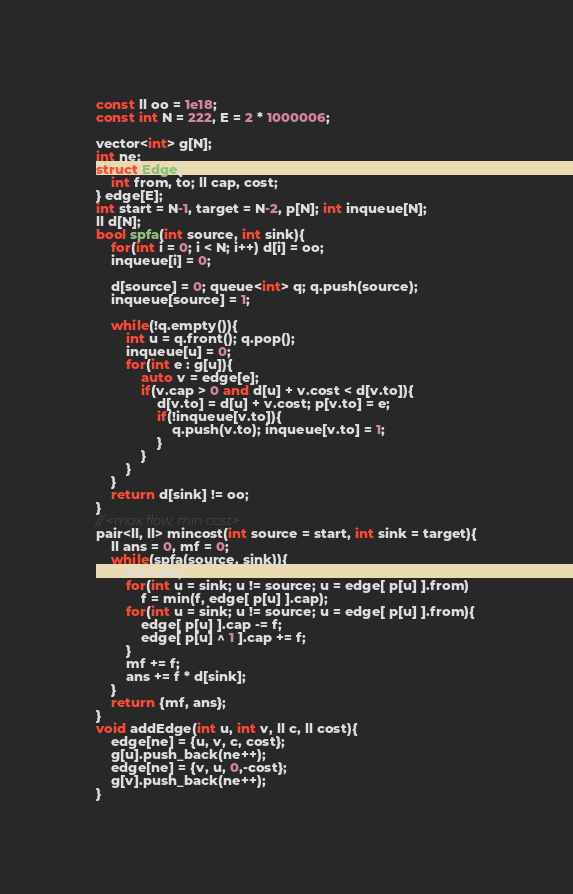<code> <loc_0><loc_0><loc_500><loc_500><_C++_>const ll oo = 1e18;
const int N = 222, E = 2 * 1000006;

vector<int> g[N];
int ne;
struct Edge{
    int from, to; ll cap, cost;
} edge[E];
int start = N-1, target = N-2, p[N]; int inqueue[N];
ll d[N];
bool spfa(int source, int sink){
    for(int i = 0; i < N; i++) d[i] = oo;
    inqueue[i] = 0;

    d[source] = 0; queue<int> q; q.push(source);
    inqueue[source] = 1;

    while(!q.empty()){
        int u = q.front(); q.pop();
        inqueue[u] = 0;
        for(int e : g[u]){
            auto v = edge[e];
            if(v.cap > 0 and d[u] + v.cost < d[v.to]){
                d[v.to] = d[u] + v.cost; p[v.to] = e;
                if(!inqueue[v.to]){
                    q.push(v.to); inqueue[v.to] = 1;
                }
            }
        }
    }
    return d[sink] != oo;
}
// <max flow, min cost>
pair<ll, ll> mincost(int source = start, int sink = target){
    ll ans = 0, mf = 0;
    while(spfa(source, sink)){
        ll f = oo;
        for(int u = sink; u != source; u = edge[ p[u] ].from)
            f = min(f, edge[ p[u] ].cap);
        for(int u = sink; u != source; u = edge[ p[u] ].from){
            edge[ p[u] ].cap -= f;
            edge[ p[u] ^ 1 ].cap += f;
        }
        mf += f;
        ans += f * d[sink];
    }
    return {mf, ans};
}
void addEdge(int u, int v, ll c, ll cost){
    edge[ne] = {u, v, c, cost};
    g[u].push_back(ne++);
    edge[ne] = {v, u, 0,-cost};
    g[v].push_back(ne++);
}
</code> 